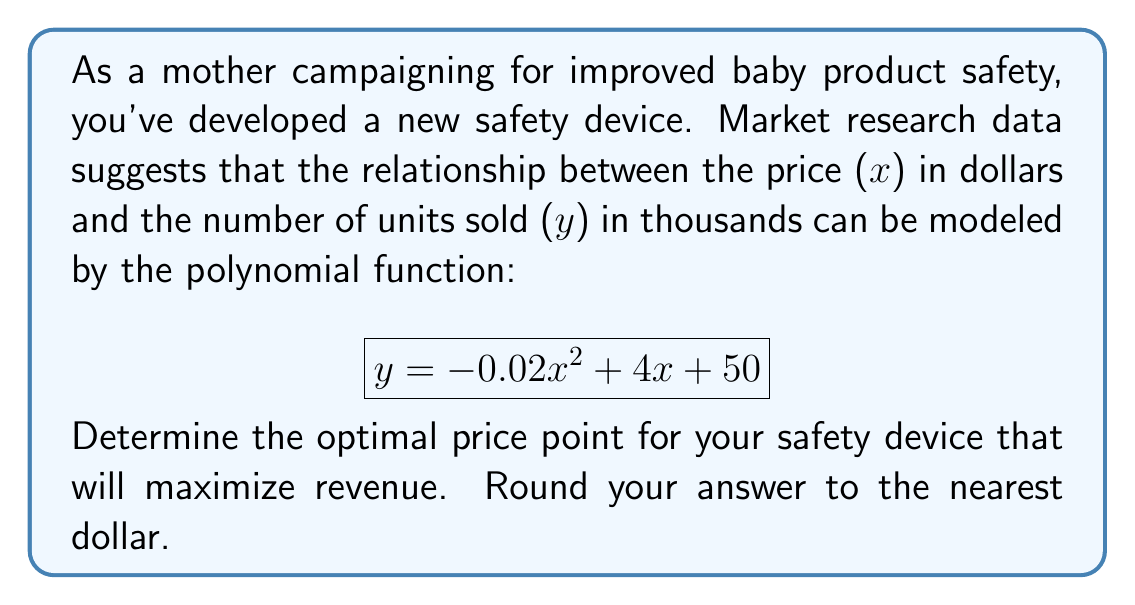Help me with this question. To find the optimal price point that maximizes revenue, we need to follow these steps:

1) Revenue (R) is calculated by multiplying the price per unit (x) by the number of units sold (y):
   $$R = xy = x(-0.02x^2 + 4x + 50)$$

2) Expand the equation:
   $$R = -0.02x^3 + 4x^2 + 50x$$

3) To find the maximum revenue, we need to find the critical points. Take the derivative of R with respect to x:
   $$\frac{dR}{dx} = -0.06x^2 + 8x + 50$$

4) Set the derivative equal to zero and solve for x:
   $$-0.06x^2 + 8x + 50 = 0$$
   
   This is a quadratic equation. We can solve it using the quadratic formula:
   $$x = \frac{-b \pm \sqrt{b^2 - 4ac}}{2a}$$
   
   Where $a = -0.06$, $b = 8$, and $c = 50$

5) Plugging in these values:
   $$x = \frac{-8 \pm \sqrt{8^2 - 4(-0.06)(50)}}{2(-0.06)}$$
   $$= \frac{-8 \pm \sqrt{64 + 12}}{-0.12}$$
   $$= \frac{-8 \pm \sqrt{76}}{-0.12}$$
   $$= \frac{-8 \pm 8.718}{-0.12}$$

6) This gives us two solutions:
   $$x_1 = \frac{-8 + 8.718}{-0.12} \approx 139.83$$
   $$x_2 = \frac{-8 - 8.718}{-0.12} \approx 5.98$$

7) The second solution (5.98) can be discarded as it's not realistic for pricing.

8) Rounding 139.83 to the nearest dollar gives us 140.

Therefore, the optimal price point that maximizes revenue is $140.
Answer: $140 